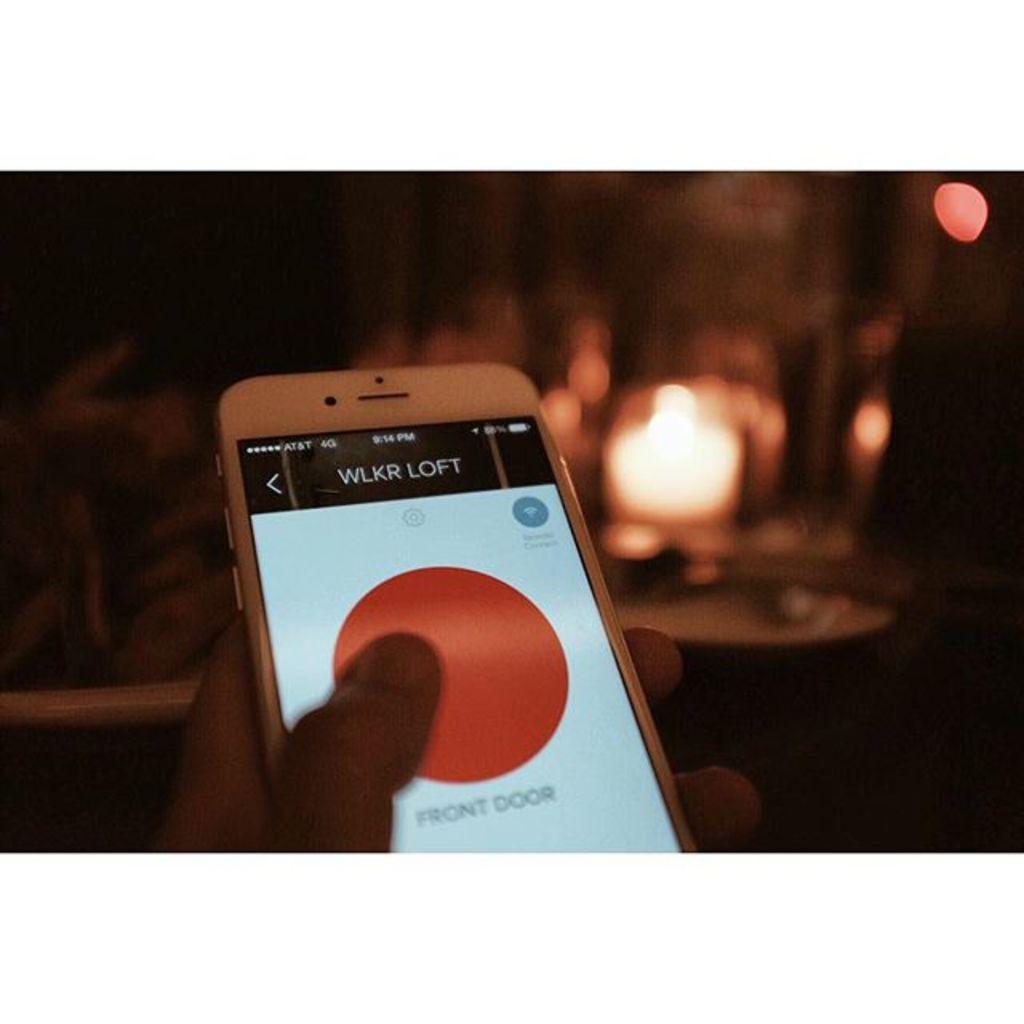Why is she opening the wlkr loft?
Provide a succinct answer. Unanswerable. 